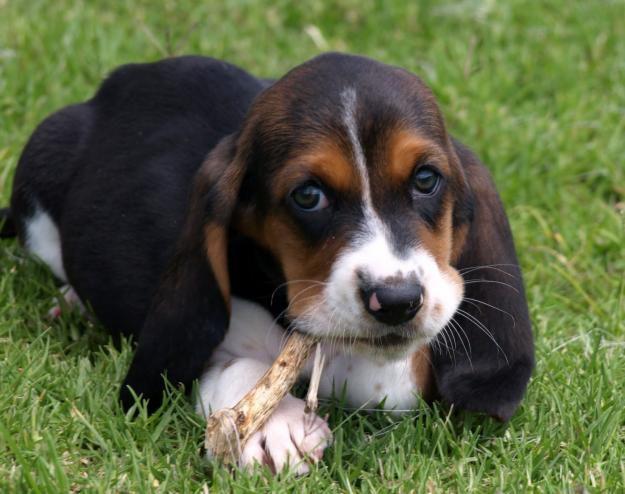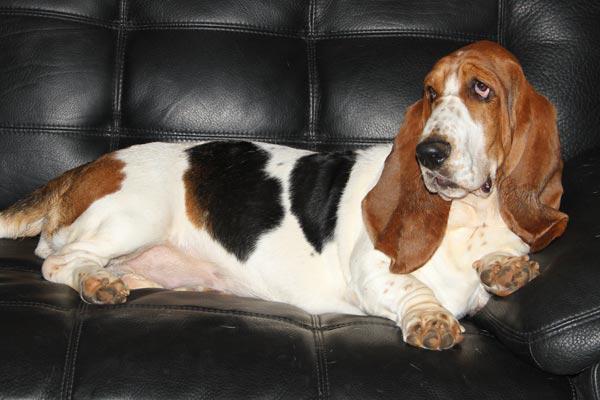The first image is the image on the left, the second image is the image on the right. Analyze the images presented: Is the assertion "There are no less than five dogs" valid? Answer yes or no. No. The first image is the image on the left, the second image is the image on the right. Assess this claim about the two images: "Right image shows exactly three basset hounds.". Correct or not? Answer yes or no. No. 